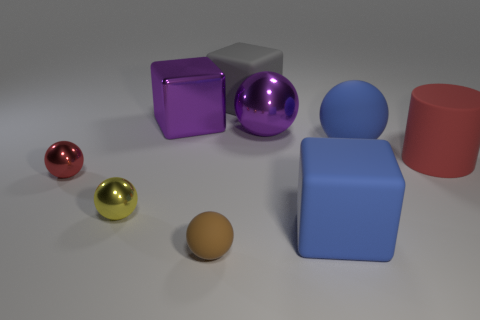Subtract all yellow spheres. How many spheres are left? 4 Subtract all yellow spheres. How many spheres are left? 4 Subtract all gray spheres. Subtract all green cylinders. How many spheres are left? 5 Add 1 metallic blocks. How many objects exist? 10 Subtract all spheres. How many objects are left? 4 Add 6 purple balls. How many purple balls are left? 7 Add 3 large brown cylinders. How many large brown cylinders exist? 3 Subtract 0 green balls. How many objects are left? 9 Subtract all small cyan shiny cubes. Subtract all small things. How many objects are left? 6 